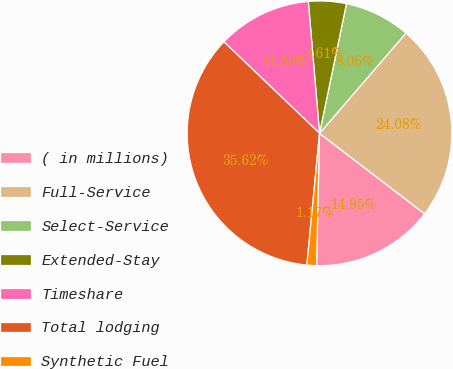Convert chart. <chart><loc_0><loc_0><loc_500><loc_500><pie_chart><fcel>( in millions)<fcel>Full-Service<fcel>Select-Service<fcel>Extended-Stay<fcel>Timeshare<fcel>Total lodging<fcel>Synthetic Fuel<nl><fcel>14.95%<fcel>24.08%<fcel>8.06%<fcel>4.61%<fcel>11.5%<fcel>35.62%<fcel>1.17%<nl></chart> 